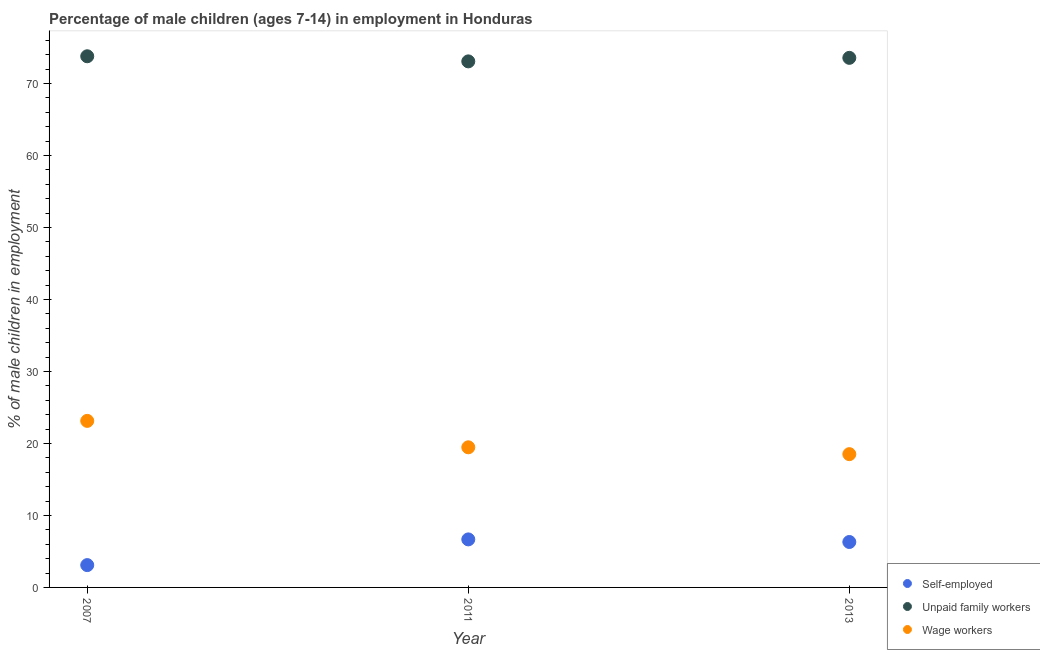How many different coloured dotlines are there?
Ensure brevity in your answer.  3. Is the number of dotlines equal to the number of legend labels?
Your response must be concise. Yes. What is the percentage of children employed as unpaid family workers in 2007?
Your answer should be very brief. 73.77. Across all years, what is the maximum percentage of children employed as unpaid family workers?
Ensure brevity in your answer.  73.77. In which year was the percentage of self employed children minimum?
Provide a short and direct response. 2007. What is the total percentage of children employed as unpaid family workers in the graph?
Keep it short and to the point. 220.38. What is the difference between the percentage of self employed children in 2011 and that in 2013?
Keep it short and to the point. 0.36. What is the difference between the percentage of children employed as wage workers in 2011 and the percentage of children employed as unpaid family workers in 2013?
Your response must be concise. -54.09. What is the average percentage of children employed as unpaid family workers per year?
Give a very brief answer. 73.46. In the year 2007, what is the difference between the percentage of children employed as unpaid family workers and percentage of self employed children?
Offer a terse response. 70.67. What is the ratio of the percentage of self employed children in 2007 to that in 2013?
Give a very brief answer. 0.49. Is the percentage of children employed as wage workers in 2007 less than that in 2013?
Your answer should be very brief. No. Is the difference between the percentage of self employed children in 2011 and 2013 greater than the difference between the percentage of children employed as wage workers in 2011 and 2013?
Offer a terse response. No. What is the difference between the highest and the second highest percentage of children employed as wage workers?
Provide a short and direct response. 3.67. What is the difference between the highest and the lowest percentage of children employed as unpaid family workers?
Ensure brevity in your answer.  0.71. In how many years, is the percentage of children employed as wage workers greater than the average percentage of children employed as wage workers taken over all years?
Offer a terse response. 1. Is the sum of the percentage of self employed children in 2007 and 2013 greater than the maximum percentage of children employed as unpaid family workers across all years?
Give a very brief answer. No. Is the percentage of children employed as wage workers strictly greater than the percentage of children employed as unpaid family workers over the years?
Keep it short and to the point. No. Is the percentage of children employed as wage workers strictly less than the percentage of self employed children over the years?
Provide a succinct answer. No. How many dotlines are there?
Provide a short and direct response. 3. Are the values on the major ticks of Y-axis written in scientific E-notation?
Offer a very short reply. No. Does the graph contain any zero values?
Offer a terse response. No. Where does the legend appear in the graph?
Provide a succinct answer. Bottom right. How many legend labels are there?
Make the answer very short. 3. What is the title of the graph?
Make the answer very short. Percentage of male children (ages 7-14) in employment in Honduras. What is the label or title of the Y-axis?
Your response must be concise. % of male children in employment. What is the % of male children in employment of Self-employed in 2007?
Ensure brevity in your answer.  3.1. What is the % of male children in employment in Unpaid family workers in 2007?
Provide a succinct answer. 73.77. What is the % of male children in employment of Wage workers in 2007?
Your answer should be compact. 23.13. What is the % of male children in employment in Self-employed in 2011?
Ensure brevity in your answer.  6.67. What is the % of male children in employment of Unpaid family workers in 2011?
Offer a terse response. 73.06. What is the % of male children in employment of Wage workers in 2011?
Offer a terse response. 19.46. What is the % of male children in employment in Self-employed in 2013?
Your response must be concise. 6.31. What is the % of male children in employment of Unpaid family workers in 2013?
Ensure brevity in your answer.  73.55. What is the % of male children in employment of Wage workers in 2013?
Your response must be concise. 18.51. Across all years, what is the maximum % of male children in employment of Self-employed?
Your answer should be very brief. 6.67. Across all years, what is the maximum % of male children in employment in Unpaid family workers?
Offer a very short reply. 73.77. Across all years, what is the maximum % of male children in employment of Wage workers?
Offer a terse response. 23.13. Across all years, what is the minimum % of male children in employment of Unpaid family workers?
Offer a very short reply. 73.06. Across all years, what is the minimum % of male children in employment in Wage workers?
Ensure brevity in your answer.  18.51. What is the total % of male children in employment of Self-employed in the graph?
Your answer should be very brief. 16.08. What is the total % of male children in employment of Unpaid family workers in the graph?
Your answer should be compact. 220.38. What is the total % of male children in employment in Wage workers in the graph?
Provide a succinct answer. 61.1. What is the difference between the % of male children in employment in Self-employed in 2007 and that in 2011?
Your response must be concise. -3.57. What is the difference between the % of male children in employment of Unpaid family workers in 2007 and that in 2011?
Your answer should be compact. 0.71. What is the difference between the % of male children in employment in Wage workers in 2007 and that in 2011?
Offer a very short reply. 3.67. What is the difference between the % of male children in employment in Self-employed in 2007 and that in 2013?
Your response must be concise. -3.21. What is the difference between the % of male children in employment in Unpaid family workers in 2007 and that in 2013?
Keep it short and to the point. 0.22. What is the difference between the % of male children in employment of Wage workers in 2007 and that in 2013?
Your answer should be compact. 4.62. What is the difference between the % of male children in employment in Self-employed in 2011 and that in 2013?
Ensure brevity in your answer.  0.36. What is the difference between the % of male children in employment in Unpaid family workers in 2011 and that in 2013?
Provide a succinct answer. -0.49. What is the difference between the % of male children in employment of Wage workers in 2011 and that in 2013?
Offer a very short reply. 0.95. What is the difference between the % of male children in employment of Self-employed in 2007 and the % of male children in employment of Unpaid family workers in 2011?
Your answer should be compact. -69.96. What is the difference between the % of male children in employment in Self-employed in 2007 and the % of male children in employment in Wage workers in 2011?
Provide a succinct answer. -16.36. What is the difference between the % of male children in employment in Unpaid family workers in 2007 and the % of male children in employment in Wage workers in 2011?
Give a very brief answer. 54.31. What is the difference between the % of male children in employment of Self-employed in 2007 and the % of male children in employment of Unpaid family workers in 2013?
Your response must be concise. -70.45. What is the difference between the % of male children in employment of Self-employed in 2007 and the % of male children in employment of Wage workers in 2013?
Offer a terse response. -15.41. What is the difference between the % of male children in employment of Unpaid family workers in 2007 and the % of male children in employment of Wage workers in 2013?
Make the answer very short. 55.26. What is the difference between the % of male children in employment of Self-employed in 2011 and the % of male children in employment of Unpaid family workers in 2013?
Keep it short and to the point. -66.88. What is the difference between the % of male children in employment of Self-employed in 2011 and the % of male children in employment of Wage workers in 2013?
Provide a succinct answer. -11.84. What is the difference between the % of male children in employment of Unpaid family workers in 2011 and the % of male children in employment of Wage workers in 2013?
Provide a succinct answer. 54.55. What is the average % of male children in employment in Self-employed per year?
Your answer should be very brief. 5.36. What is the average % of male children in employment of Unpaid family workers per year?
Your answer should be very brief. 73.46. What is the average % of male children in employment of Wage workers per year?
Keep it short and to the point. 20.37. In the year 2007, what is the difference between the % of male children in employment of Self-employed and % of male children in employment of Unpaid family workers?
Your answer should be very brief. -70.67. In the year 2007, what is the difference between the % of male children in employment of Self-employed and % of male children in employment of Wage workers?
Ensure brevity in your answer.  -20.03. In the year 2007, what is the difference between the % of male children in employment in Unpaid family workers and % of male children in employment in Wage workers?
Your answer should be compact. 50.64. In the year 2011, what is the difference between the % of male children in employment in Self-employed and % of male children in employment in Unpaid family workers?
Give a very brief answer. -66.39. In the year 2011, what is the difference between the % of male children in employment of Self-employed and % of male children in employment of Wage workers?
Keep it short and to the point. -12.79. In the year 2011, what is the difference between the % of male children in employment in Unpaid family workers and % of male children in employment in Wage workers?
Your response must be concise. 53.6. In the year 2013, what is the difference between the % of male children in employment of Self-employed and % of male children in employment of Unpaid family workers?
Give a very brief answer. -67.24. In the year 2013, what is the difference between the % of male children in employment of Self-employed and % of male children in employment of Wage workers?
Offer a very short reply. -12.2. In the year 2013, what is the difference between the % of male children in employment of Unpaid family workers and % of male children in employment of Wage workers?
Your response must be concise. 55.04. What is the ratio of the % of male children in employment of Self-employed in 2007 to that in 2011?
Provide a succinct answer. 0.46. What is the ratio of the % of male children in employment of Unpaid family workers in 2007 to that in 2011?
Keep it short and to the point. 1.01. What is the ratio of the % of male children in employment of Wage workers in 2007 to that in 2011?
Keep it short and to the point. 1.19. What is the ratio of the % of male children in employment in Self-employed in 2007 to that in 2013?
Ensure brevity in your answer.  0.49. What is the ratio of the % of male children in employment of Unpaid family workers in 2007 to that in 2013?
Ensure brevity in your answer.  1. What is the ratio of the % of male children in employment of Wage workers in 2007 to that in 2013?
Provide a succinct answer. 1.25. What is the ratio of the % of male children in employment in Self-employed in 2011 to that in 2013?
Provide a short and direct response. 1.06. What is the ratio of the % of male children in employment in Wage workers in 2011 to that in 2013?
Provide a succinct answer. 1.05. What is the difference between the highest and the second highest % of male children in employment of Self-employed?
Your answer should be very brief. 0.36. What is the difference between the highest and the second highest % of male children in employment of Unpaid family workers?
Make the answer very short. 0.22. What is the difference between the highest and the second highest % of male children in employment in Wage workers?
Offer a terse response. 3.67. What is the difference between the highest and the lowest % of male children in employment in Self-employed?
Your response must be concise. 3.57. What is the difference between the highest and the lowest % of male children in employment in Unpaid family workers?
Offer a terse response. 0.71. What is the difference between the highest and the lowest % of male children in employment of Wage workers?
Give a very brief answer. 4.62. 